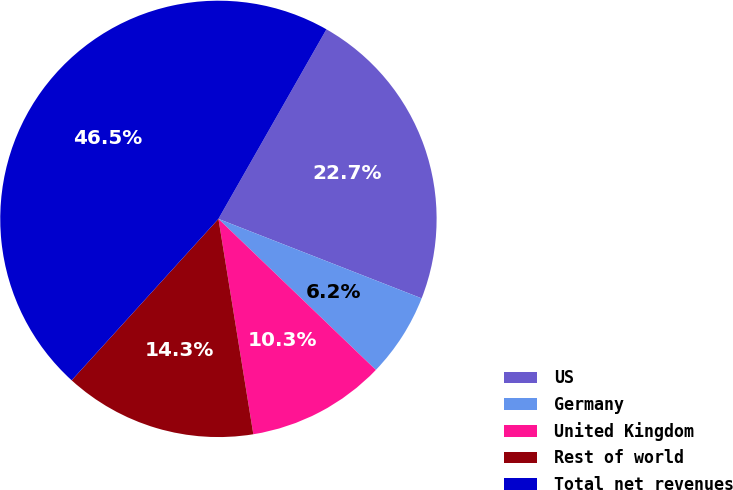Convert chart. <chart><loc_0><loc_0><loc_500><loc_500><pie_chart><fcel>US<fcel>Germany<fcel>United Kingdom<fcel>Rest of world<fcel>Total net revenues<nl><fcel>22.69%<fcel>6.24%<fcel>10.27%<fcel>14.3%<fcel>46.5%<nl></chart> 